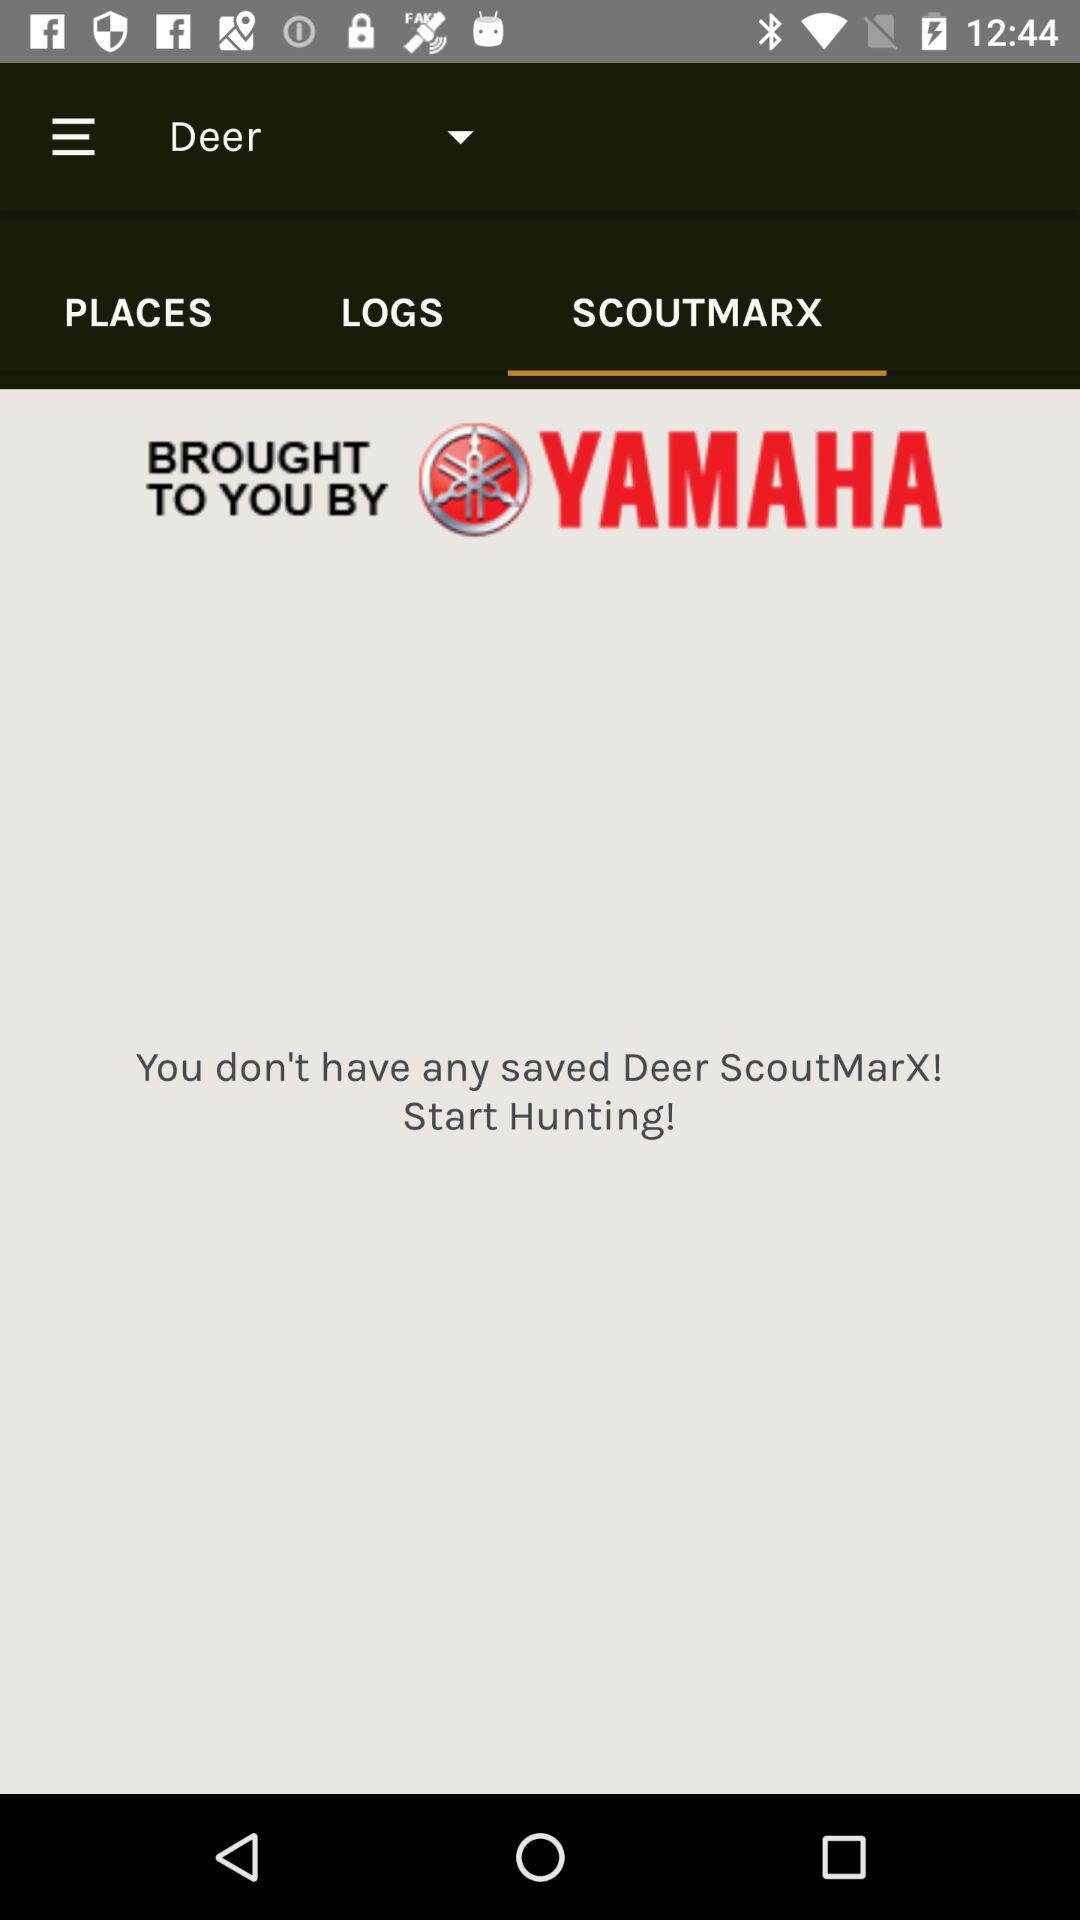Is there any saved "ScoutMarX"? There is no saved "ScoutMarX". 